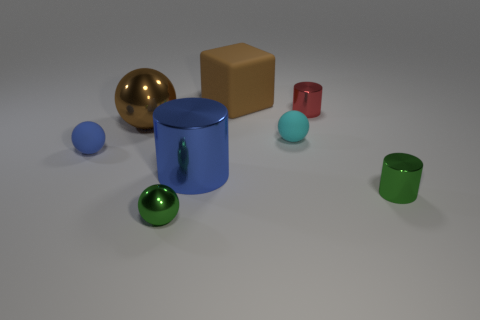Subtract all cyan balls. How many balls are left? 3 Subtract all tiny green metallic balls. How many balls are left? 3 Subtract all red spheres. Subtract all blue cylinders. How many spheres are left? 4 Add 1 big cyan shiny things. How many objects exist? 9 Subtract all cylinders. How many objects are left? 5 Add 8 blue shiny cylinders. How many blue shiny cylinders are left? 9 Add 6 tiny gray metallic spheres. How many tiny gray metallic spheres exist? 6 Subtract 1 brown cubes. How many objects are left? 7 Subtract all rubber blocks. Subtract all big shiny things. How many objects are left? 5 